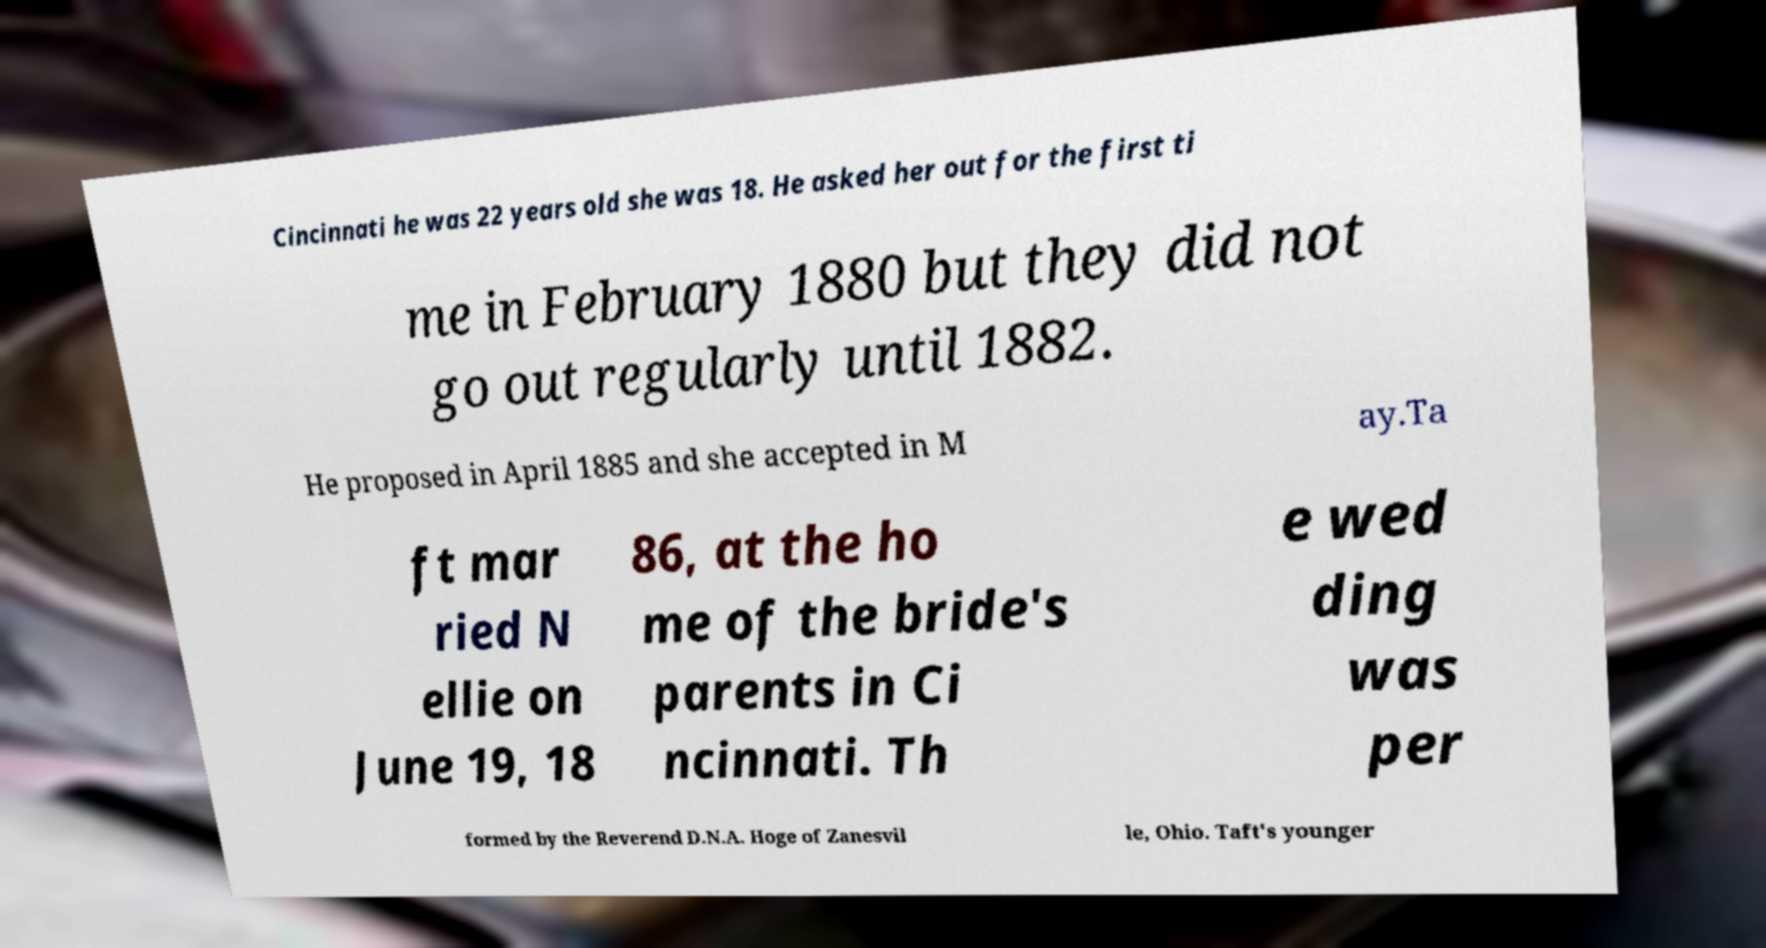Could you extract and type out the text from this image? Cincinnati he was 22 years old she was 18. He asked her out for the first ti me in February 1880 but they did not go out regularly until 1882. He proposed in April 1885 and she accepted in M ay.Ta ft mar ried N ellie on June 19, 18 86, at the ho me of the bride's parents in Ci ncinnati. Th e wed ding was per formed by the Reverend D.N.A. Hoge of Zanesvil le, Ohio. Taft's younger 